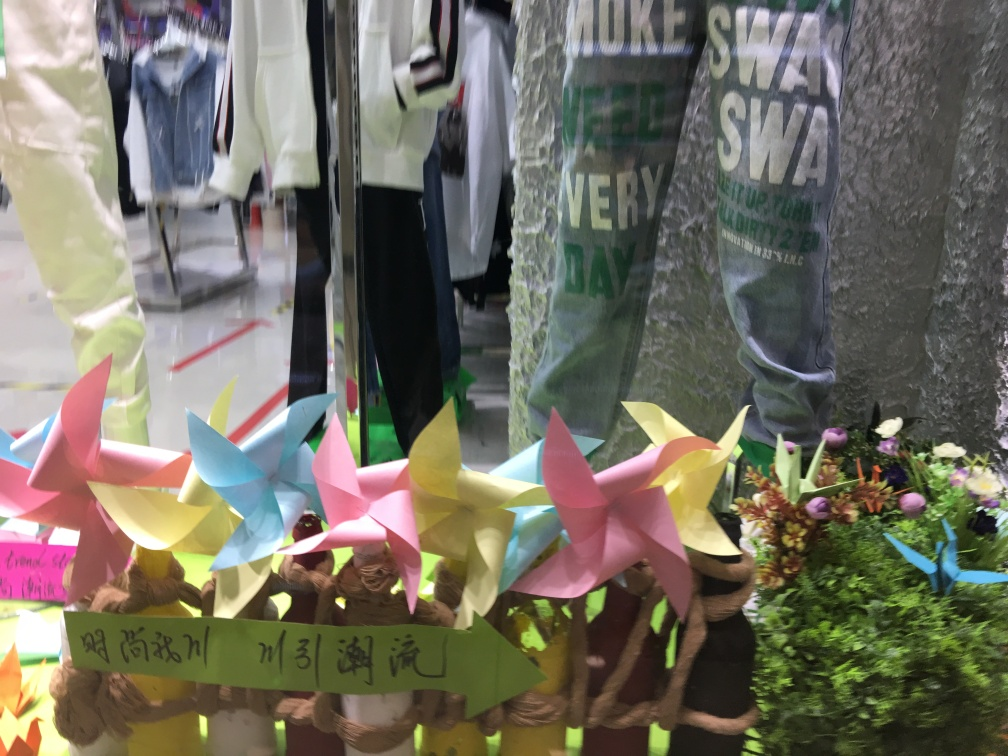Are there any quality issues with this image? Yes, the image exhibits a few quality issues. Firstly, it appears to be slightly out of focus, particularly in the background, affecting overall sharpness. Secondly, there's notable glare and reflections on the glass surface, likely from indoor lighting, which obscures parts of the image. Lastly, the composition is somewhat cluttered, making it hard to distinguish individual elements clearly. 